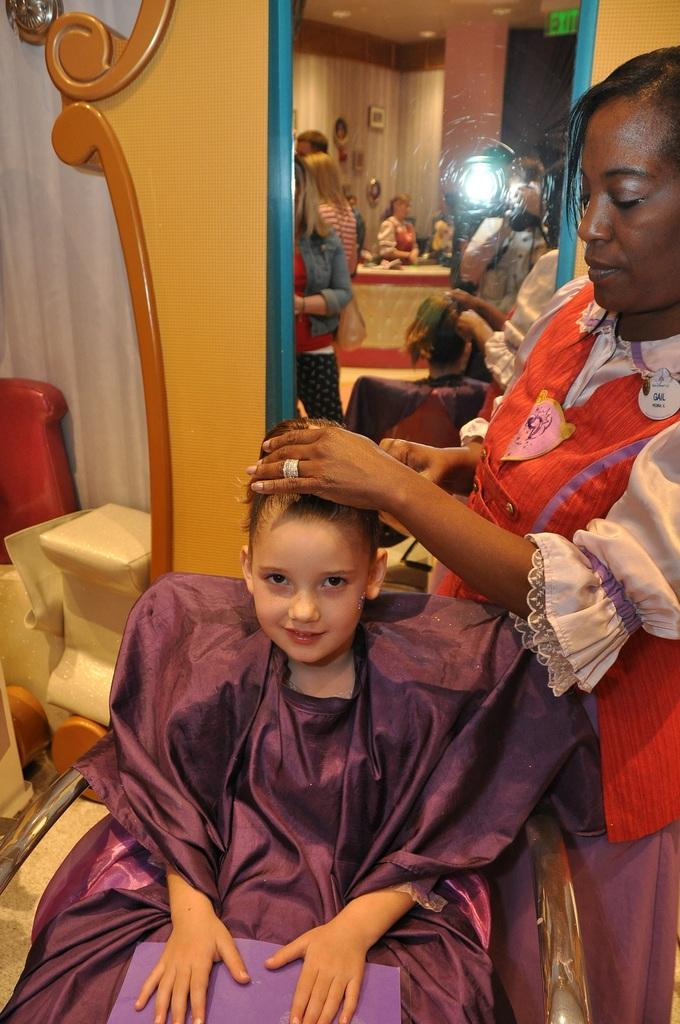What type of structure can be seen in the image? There is a wall in the image. What is hanging on the wall? There is a curtain in the image. Who or what is present in the image? There is a group of people in the image. What object can be used for reflection in the image? There is a mirror in the image. What type of furniture is visible in the image? There is a chair in the image. Where is the woman located in the image? The woman is standing on the right side of the image. What color is the dress the woman is wearing? The woman is wearing an orange color dress. What type of noise can be heard coming from the mirror in the image? There is no noise coming from the mirror in the image. How does the woman's breath affect the curtain in the image? The woman's breath does not affect the curtain in the image, as there is no interaction between them. 